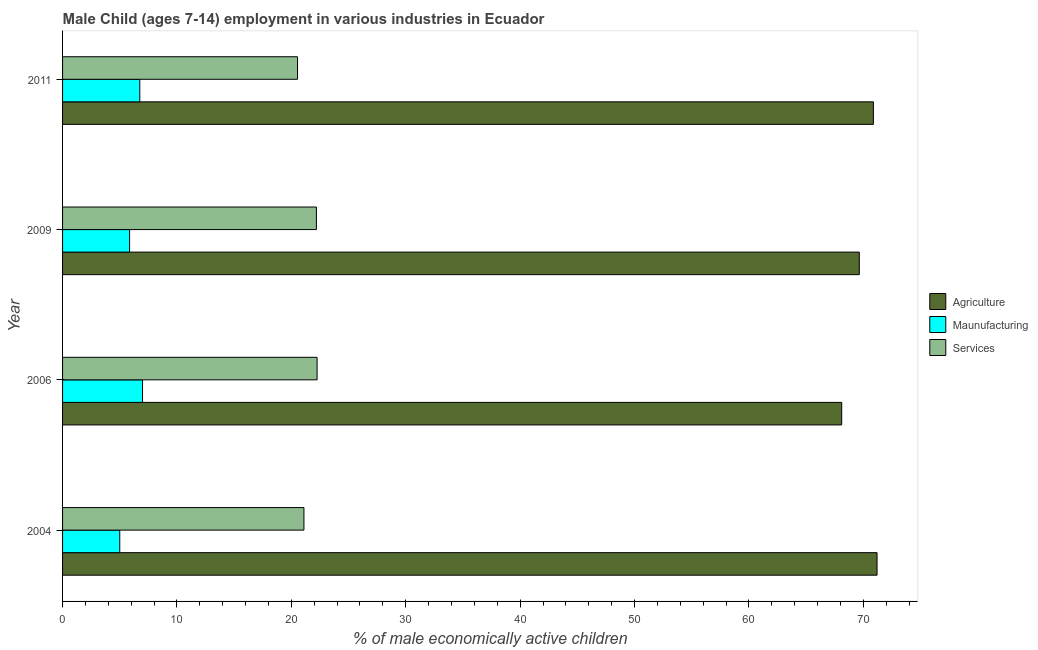How many different coloured bars are there?
Provide a succinct answer. 3. How many groups of bars are there?
Provide a succinct answer. 4. Are the number of bars on each tick of the Y-axis equal?
Provide a short and direct response. Yes. How many bars are there on the 4th tick from the top?
Offer a very short reply. 3. How many bars are there on the 4th tick from the bottom?
Offer a terse response. 3. What is the percentage of economically active children in agriculture in 2004?
Your response must be concise. 71.2. Across all years, what is the maximum percentage of economically active children in manufacturing?
Your answer should be compact. 6.99. Across all years, what is the minimum percentage of economically active children in agriculture?
Give a very brief answer. 68.11. In which year was the percentage of economically active children in manufacturing maximum?
Keep it short and to the point. 2006. What is the total percentage of economically active children in agriculture in the graph?
Provide a succinct answer. 279.84. What is the difference between the percentage of economically active children in manufacturing in 2004 and that in 2009?
Make the answer very short. -0.86. What is the difference between the percentage of economically active children in services in 2006 and the percentage of economically active children in manufacturing in 2011?
Your response must be concise. 15.5. What is the average percentage of economically active children in services per year?
Offer a very short reply. 21.52. In how many years, is the percentage of economically active children in agriculture greater than 12 %?
Provide a short and direct response. 4. What is the ratio of the percentage of economically active children in services in 2004 to that in 2009?
Ensure brevity in your answer.  0.95. Is the percentage of economically active children in manufacturing in 2009 less than that in 2011?
Your answer should be very brief. Yes. What is the difference between the highest and the second highest percentage of economically active children in agriculture?
Your answer should be very brief. 0.32. What is the difference between the highest and the lowest percentage of economically active children in agriculture?
Ensure brevity in your answer.  3.09. Is the sum of the percentage of economically active children in agriculture in 2004 and 2006 greater than the maximum percentage of economically active children in manufacturing across all years?
Keep it short and to the point. Yes. What does the 1st bar from the top in 2006 represents?
Give a very brief answer. Services. What does the 3rd bar from the bottom in 2011 represents?
Your answer should be compact. Services. How many bars are there?
Offer a terse response. 12. What is the difference between two consecutive major ticks on the X-axis?
Offer a terse response. 10. Are the values on the major ticks of X-axis written in scientific E-notation?
Offer a very short reply. No. How many legend labels are there?
Make the answer very short. 3. How are the legend labels stacked?
Offer a terse response. Vertical. What is the title of the graph?
Provide a succinct answer. Male Child (ages 7-14) employment in various industries in Ecuador. Does "Ages 15-64" appear as one of the legend labels in the graph?
Keep it short and to the point. No. What is the label or title of the X-axis?
Your answer should be compact. % of male economically active children. What is the label or title of the Y-axis?
Offer a terse response. Year. What is the % of male economically active children in Agriculture in 2004?
Give a very brief answer. 71.2. What is the % of male economically active children in Maunufacturing in 2004?
Provide a succinct answer. 5. What is the % of male economically active children of Services in 2004?
Provide a succinct answer. 21.1. What is the % of male economically active children in Agriculture in 2006?
Provide a succinct answer. 68.11. What is the % of male economically active children of Maunufacturing in 2006?
Make the answer very short. 6.99. What is the % of male economically active children of Services in 2006?
Ensure brevity in your answer.  22.25. What is the % of male economically active children of Agriculture in 2009?
Ensure brevity in your answer.  69.65. What is the % of male economically active children of Maunufacturing in 2009?
Ensure brevity in your answer.  5.86. What is the % of male economically active children in Services in 2009?
Offer a very short reply. 22.19. What is the % of male economically active children in Agriculture in 2011?
Make the answer very short. 70.88. What is the % of male economically active children of Maunufacturing in 2011?
Give a very brief answer. 6.75. What is the % of male economically active children of Services in 2011?
Make the answer very short. 20.54. Across all years, what is the maximum % of male economically active children of Agriculture?
Give a very brief answer. 71.2. Across all years, what is the maximum % of male economically active children of Maunufacturing?
Offer a very short reply. 6.99. Across all years, what is the maximum % of male economically active children of Services?
Ensure brevity in your answer.  22.25. Across all years, what is the minimum % of male economically active children of Agriculture?
Keep it short and to the point. 68.11. Across all years, what is the minimum % of male economically active children in Maunufacturing?
Provide a succinct answer. 5. Across all years, what is the minimum % of male economically active children in Services?
Provide a short and direct response. 20.54. What is the total % of male economically active children in Agriculture in the graph?
Make the answer very short. 279.84. What is the total % of male economically active children of Maunufacturing in the graph?
Offer a terse response. 24.6. What is the total % of male economically active children of Services in the graph?
Provide a succinct answer. 86.08. What is the difference between the % of male economically active children in Agriculture in 2004 and that in 2006?
Your response must be concise. 3.09. What is the difference between the % of male economically active children in Maunufacturing in 2004 and that in 2006?
Your response must be concise. -1.99. What is the difference between the % of male economically active children of Services in 2004 and that in 2006?
Offer a very short reply. -1.15. What is the difference between the % of male economically active children in Agriculture in 2004 and that in 2009?
Ensure brevity in your answer.  1.55. What is the difference between the % of male economically active children in Maunufacturing in 2004 and that in 2009?
Your answer should be compact. -0.86. What is the difference between the % of male economically active children in Services in 2004 and that in 2009?
Your answer should be very brief. -1.09. What is the difference between the % of male economically active children in Agriculture in 2004 and that in 2011?
Give a very brief answer. 0.32. What is the difference between the % of male economically active children of Maunufacturing in 2004 and that in 2011?
Make the answer very short. -1.75. What is the difference between the % of male economically active children in Services in 2004 and that in 2011?
Your answer should be compact. 0.56. What is the difference between the % of male economically active children in Agriculture in 2006 and that in 2009?
Make the answer very short. -1.54. What is the difference between the % of male economically active children of Maunufacturing in 2006 and that in 2009?
Your response must be concise. 1.13. What is the difference between the % of male economically active children in Services in 2006 and that in 2009?
Provide a succinct answer. 0.06. What is the difference between the % of male economically active children in Agriculture in 2006 and that in 2011?
Provide a short and direct response. -2.77. What is the difference between the % of male economically active children of Maunufacturing in 2006 and that in 2011?
Make the answer very short. 0.24. What is the difference between the % of male economically active children in Services in 2006 and that in 2011?
Keep it short and to the point. 1.71. What is the difference between the % of male economically active children of Agriculture in 2009 and that in 2011?
Provide a short and direct response. -1.23. What is the difference between the % of male economically active children of Maunufacturing in 2009 and that in 2011?
Ensure brevity in your answer.  -0.89. What is the difference between the % of male economically active children in Services in 2009 and that in 2011?
Give a very brief answer. 1.65. What is the difference between the % of male economically active children of Agriculture in 2004 and the % of male economically active children of Maunufacturing in 2006?
Keep it short and to the point. 64.21. What is the difference between the % of male economically active children of Agriculture in 2004 and the % of male economically active children of Services in 2006?
Your answer should be compact. 48.95. What is the difference between the % of male economically active children of Maunufacturing in 2004 and the % of male economically active children of Services in 2006?
Provide a short and direct response. -17.25. What is the difference between the % of male economically active children of Agriculture in 2004 and the % of male economically active children of Maunufacturing in 2009?
Offer a very short reply. 65.34. What is the difference between the % of male economically active children of Agriculture in 2004 and the % of male economically active children of Services in 2009?
Give a very brief answer. 49.01. What is the difference between the % of male economically active children of Maunufacturing in 2004 and the % of male economically active children of Services in 2009?
Give a very brief answer. -17.19. What is the difference between the % of male economically active children in Agriculture in 2004 and the % of male economically active children in Maunufacturing in 2011?
Your answer should be compact. 64.45. What is the difference between the % of male economically active children of Agriculture in 2004 and the % of male economically active children of Services in 2011?
Offer a terse response. 50.66. What is the difference between the % of male economically active children of Maunufacturing in 2004 and the % of male economically active children of Services in 2011?
Give a very brief answer. -15.54. What is the difference between the % of male economically active children of Agriculture in 2006 and the % of male economically active children of Maunufacturing in 2009?
Provide a succinct answer. 62.25. What is the difference between the % of male economically active children in Agriculture in 2006 and the % of male economically active children in Services in 2009?
Offer a terse response. 45.92. What is the difference between the % of male economically active children of Maunufacturing in 2006 and the % of male economically active children of Services in 2009?
Make the answer very short. -15.2. What is the difference between the % of male economically active children of Agriculture in 2006 and the % of male economically active children of Maunufacturing in 2011?
Your answer should be very brief. 61.36. What is the difference between the % of male economically active children of Agriculture in 2006 and the % of male economically active children of Services in 2011?
Offer a terse response. 47.57. What is the difference between the % of male economically active children in Maunufacturing in 2006 and the % of male economically active children in Services in 2011?
Your response must be concise. -13.55. What is the difference between the % of male economically active children of Agriculture in 2009 and the % of male economically active children of Maunufacturing in 2011?
Provide a succinct answer. 62.9. What is the difference between the % of male economically active children in Agriculture in 2009 and the % of male economically active children in Services in 2011?
Give a very brief answer. 49.11. What is the difference between the % of male economically active children in Maunufacturing in 2009 and the % of male economically active children in Services in 2011?
Provide a succinct answer. -14.68. What is the average % of male economically active children in Agriculture per year?
Give a very brief answer. 69.96. What is the average % of male economically active children in Maunufacturing per year?
Your response must be concise. 6.15. What is the average % of male economically active children of Services per year?
Offer a very short reply. 21.52. In the year 2004, what is the difference between the % of male economically active children of Agriculture and % of male economically active children of Maunufacturing?
Make the answer very short. 66.2. In the year 2004, what is the difference between the % of male economically active children in Agriculture and % of male economically active children in Services?
Ensure brevity in your answer.  50.1. In the year 2004, what is the difference between the % of male economically active children in Maunufacturing and % of male economically active children in Services?
Offer a terse response. -16.1. In the year 2006, what is the difference between the % of male economically active children of Agriculture and % of male economically active children of Maunufacturing?
Ensure brevity in your answer.  61.12. In the year 2006, what is the difference between the % of male economically active children in Agriculture and % of male economically active children in Services?
Ensure brevity in your answer.  45.86. In the year 2006, what is the difference between the % of male economically active children in Maunufacturing and % of male economically active children in Services?
Make the answer very short. -15.26. In the year 2009, what is the difference between the % of male economically active children of Agriculture and % of male economically active children of Maunufacturing?
Provide a short and direct response. 63.79. In the year 2009, what is the difference between the % of male economically active children in Agriculture and % of male economically active children in Services?
Make the answer very short. 47.46. In the year 2009, what is the difference between the % of male economically active children in Maunufacturing and % of male economically active children in Services?
Ensure brevity in your answer.  -16.33. In the year 2011, what is the difference between the % of male economically active children in Agriculture and % of male economically active children in Maunufacturing?
Your response must be concise. 64.13. In the year 2011, what is the difference between the % of male economically active children of Agriculture and % of male economically active children of Services?
Your answer should be compact. 50.34. In the year 2011, what is the difference between the % of male economically active children in Maunufacturing and % of male economically active children in Services?
Make the answer very short. -13.79. What is the ratio of the % of male economically active children of Agriculture in 2004 to that in 2006?
Keep it short and to the point. 1.05. What is the ratio of the % of male economically active children of Maunufacturing in 2004 to that in 2006?
Make the answer very short. 0.72. What is the ratio of the % of male economically active children in Services in 2004 to that in 2006?
Your answer should be very brief. 0.95. What is the ratio of the % of male economically active children in Agriculture in 2004 to that in 2009?
Make the answer very short. 1.02. What is the ratio of the % of male economically active children of Maunufacturing in 2004 to that in 2009?
Give a very brief answer. 0.85. What is the ratio of the % of male economically active children in Services in 2004 to that in 2009?
Offer a very short reply. 0.95. What is the ratio of the % of male economically active children in Maunufacturing in 2004 to that in 2011?
Your answer should be compact. 0.74. What is the ratio of the % of male economically active children of Services in 2004 to that in 2011?
Offer a terse response. 1.03. What is the ratio of the % of male economically active children of Agriculture in 2006 to that in 2009?
Your response must be concise. 0.98. What is the ratio of the % of male economically active children in Maunufacturing in 2006 to that in 2009?
Your answer should be very brief. 1.19. What is the ratio of the % of male economically active children of Agriculture in 2006 to that in 2011?
Your answer should be very brief. 0.96. What is the ratio of the % of male economically active children in Maunufacturing in 2006 to that in 2011?
Provide a short and direct response. 1.04. What is the ratio of the % of male economically active children of Services in 2006 to that in 2011?
Provide a short and direct response. 1.08. What is the ratio of the % of male economically active children of Agriculture in 2009 to that in 2011?
Offer a terse response. 0.98. What is the ratio of the % of male economically active children of Maunufacturing in 2009 to that in 2011?
Ensure brevity in your answer.  0.87. What is the ratio of the % of male economically active children of Services in 2009 to that in 2011?
Make the answer very short. 1.08. What is the difference between the highest and the second highest % of male economically active children of Agriculture?
Give a very brief answer. 0.32. What is the difference between the highest and the second highest % of male economically active children in Maunufacturing?
Offer a very short reply. 0.24. What is the difference between the highest and the second highest % of male economically active children of Services?
Give a very brief answer. 0.06. What is the difference between the highest and the lowest % of male economically active children of Agriculture?
Make the answer very short. 3.09. What is the difference between the highest and the lowest % of male economically active children of Maunufacturing?
Offer a terse response. 1.99. What is the difference between the highest and the lowest % of male economically active children in Services?
Give a very brief answer. 1.71. 